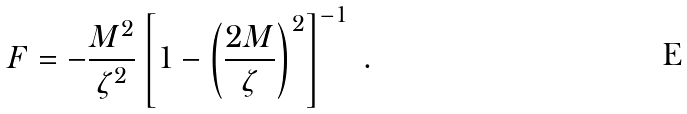<formula> <loc_0><loc_0><loc_500><loc_500>F = - \frac { M ^ { 2 } } { \zeta ^ { 2 } } \left [ 1 - \left ( \frac { 2 M } { \zeta } \right ) ^ { 2 } \right ] ^ { - 1 } \ .</formula> 